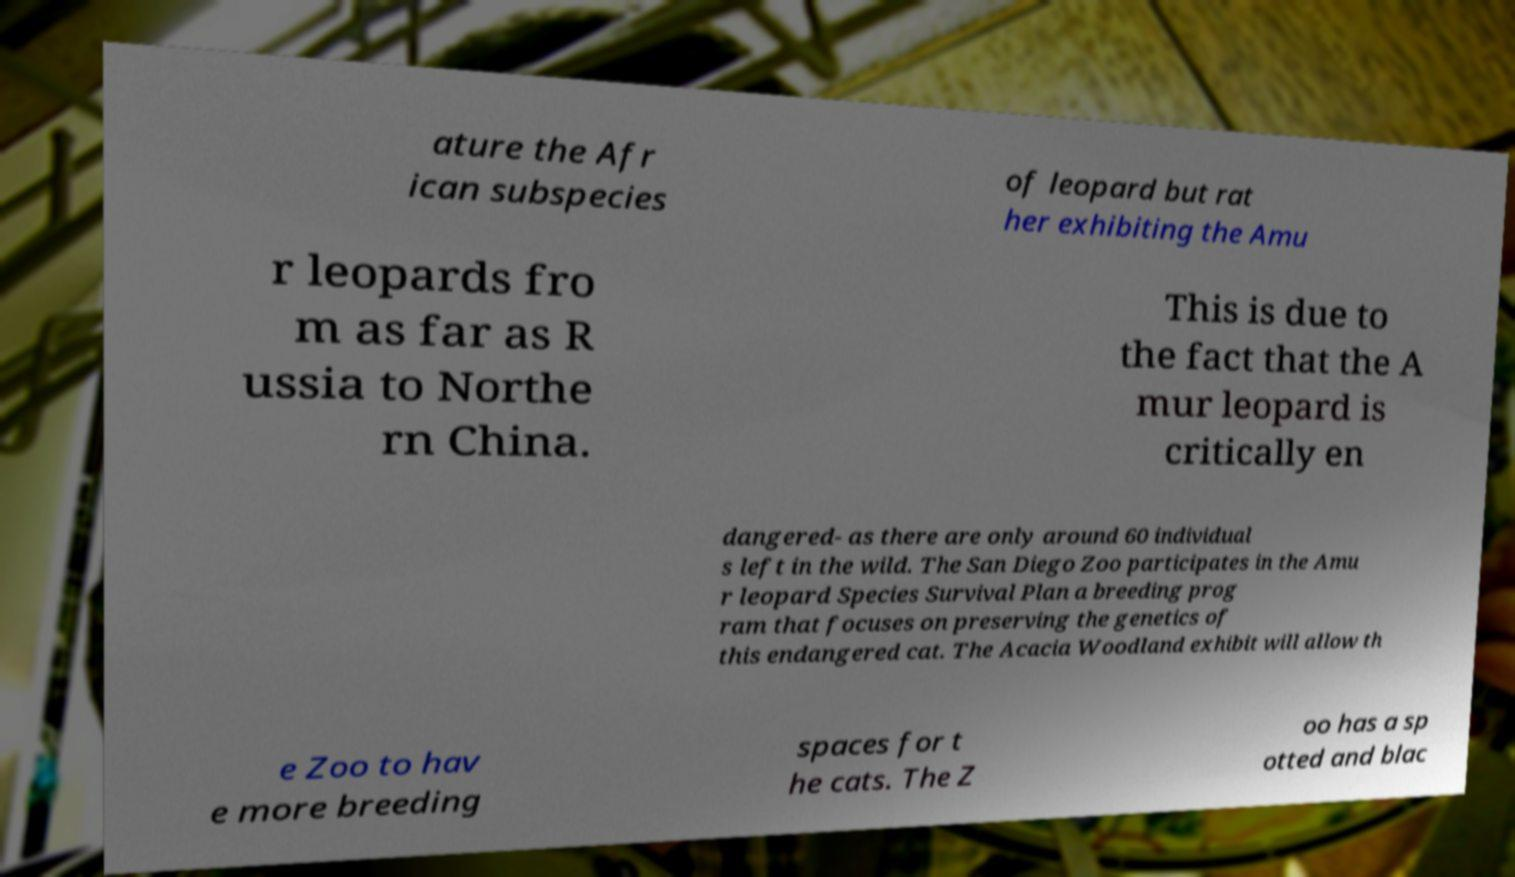Please identify and transcribe the text found in this image. ature the Afr ican subspecies of leopard but rat her exhibiting the Amu r leopards fro m as far as R ussia to Northe rn China. This is due to the fact that the A mur leopard is critically en dangered- as there are only around 60 individual s left in the wild. The San Diego Zoo participates in the Amu r leopard Species Survival Plan a breeding prog ram that focuses on preserving the genetics of this endangered cat. The Acacia Woodland exhibit will allow th e Zoo to hav e more breeding spaces for t he cats. The Z oo has a sp otted and blac 